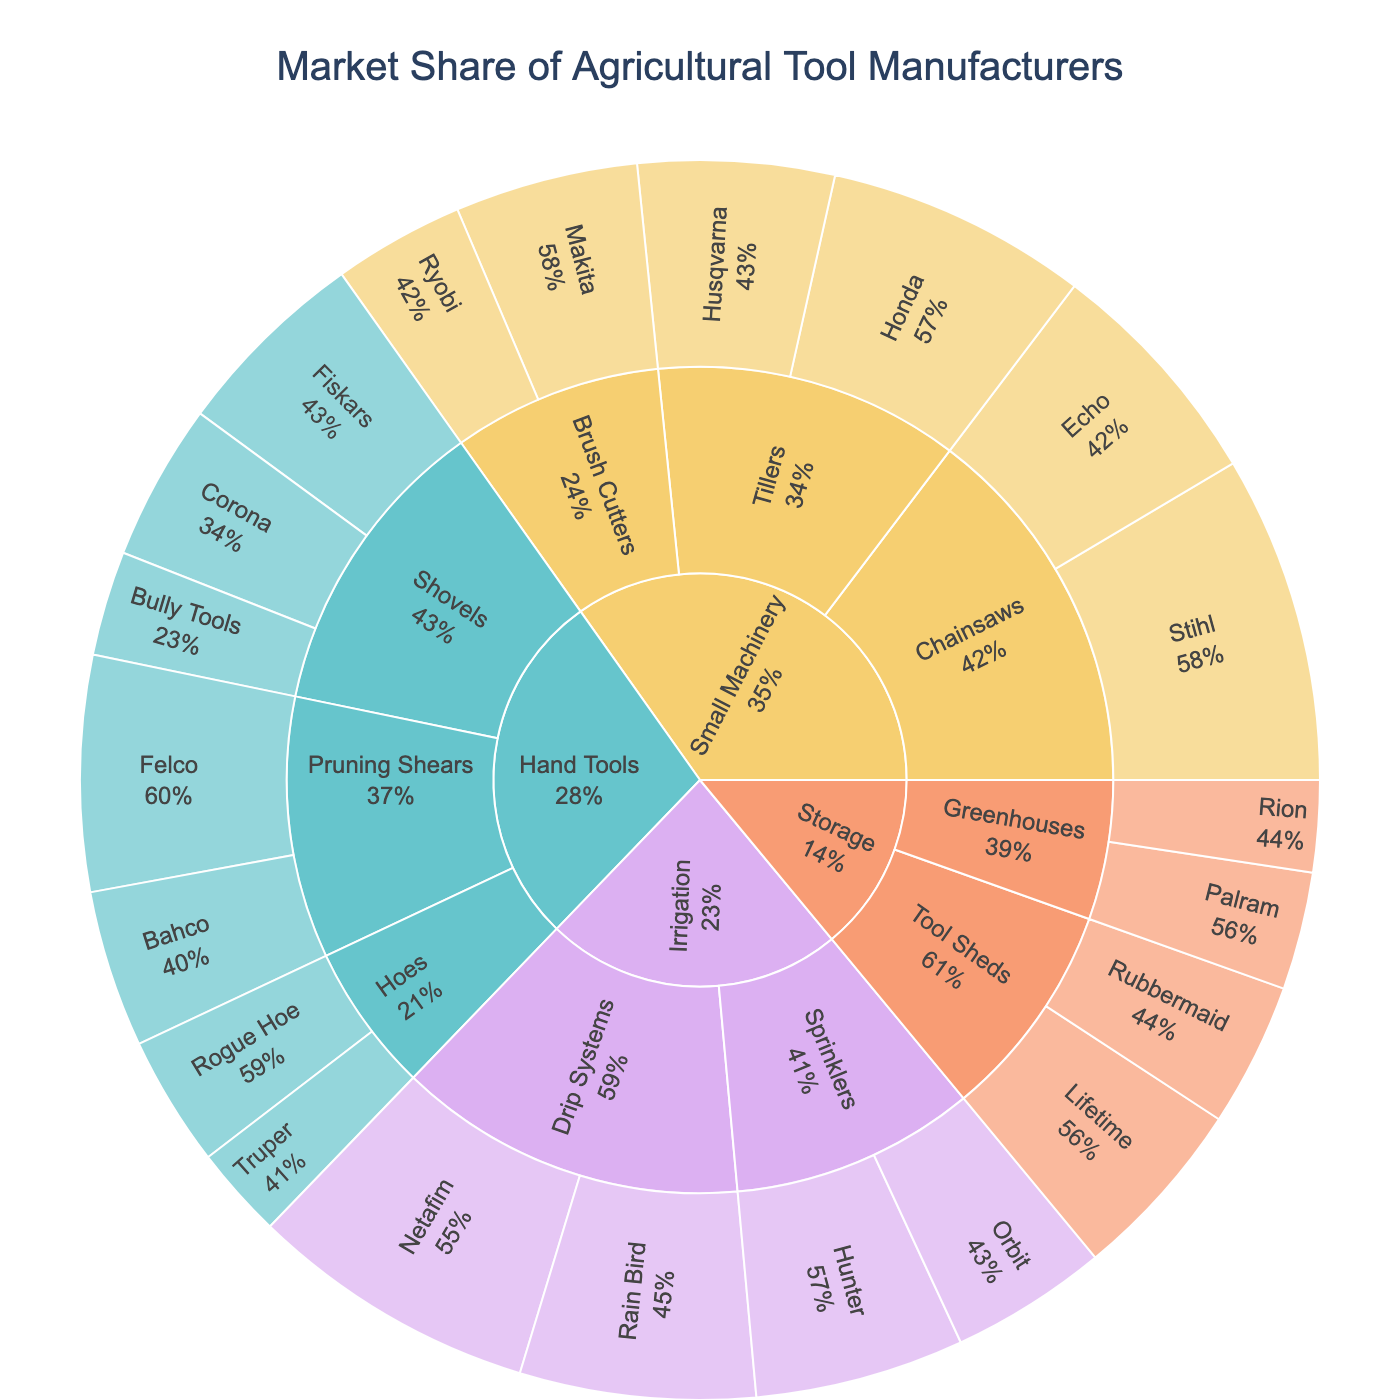what is the title of the figure? The title is usually located at the top of the chart and it summarizes what the data represents. By looking at the top part of the Sunburst Plot, we see the title "Market Share of Agricultural Tool Manufacturers".
Answer: Market Share of Agricultural Tool Manufacturers Which brand has the highest market share in the Small Machinery category? To answer this, we identify which brands belong to the Small Machinery category and compare their market shares. Stihl, with a 25% market share in Chainsaws, has the highest within this category.
Answer: Stihl What is the combined market share of Fiskars, Corona, and Bully Tools in the Shovels subcategory? First, we sum up the market shares of the mentioned brands: Fiskars (15%) + Corona (12%) + Bully Tools (8%) = 35%.
Answer: 35% Which Irrigation subcategory has the highest market share and what is its value? By comparing the Drip Systems and Sprinklers subcategories, we see that Drip Systems have higher combined market shares of 22% (Netafim) + 18% (Rain Bird) = 40%, while Sprinklers have 16% (Hunter) + 12% (Orbit) = 28%. Thus, Drip Systems have the highest market share with 40%.
Answer: Drip Systems with 40% Compare the market share of Pruning Shears across brands Felco and Bahco. Which is higher and by how much? Felco has an 18% market share and Bahco has 12%. The difference between them is 18% - 12% = 6%. Felco has a 6% higher market share.
Answer: Felco by 6% What percentage of the total market share does the Hand Tools category represent? We sum up the market shares of all subcategories within Hand Tools: Shovels (15+12+8) + Hoes (10+7) + Pruning Shears (18+12) = 42 + 17 + 30 = 89%. Hand Tools category has an 89% market share.
Answer: 89% Which tool type has the highest diversity in manufacturers? By counting the number of brands in each tool type: 
  - Hand Tools: 7 brands
  - Small Machinery: 6 brands
  - Irrigation: 4 brands
  - Storage: 4 brands 
Hand Tools have the highest number of different manufacturers.
Answer: Hand Tools Is there any brand under the Storage category that has less than a 10% market share? First we identify the brands under the Storage category and check their market shares: Lifetime (14%), Rubbermaid (11%), Palram (9%), Rion (7%). Both Palram and Rion have less than a 10% market share.
Answer: Yes, Palram and Rion 